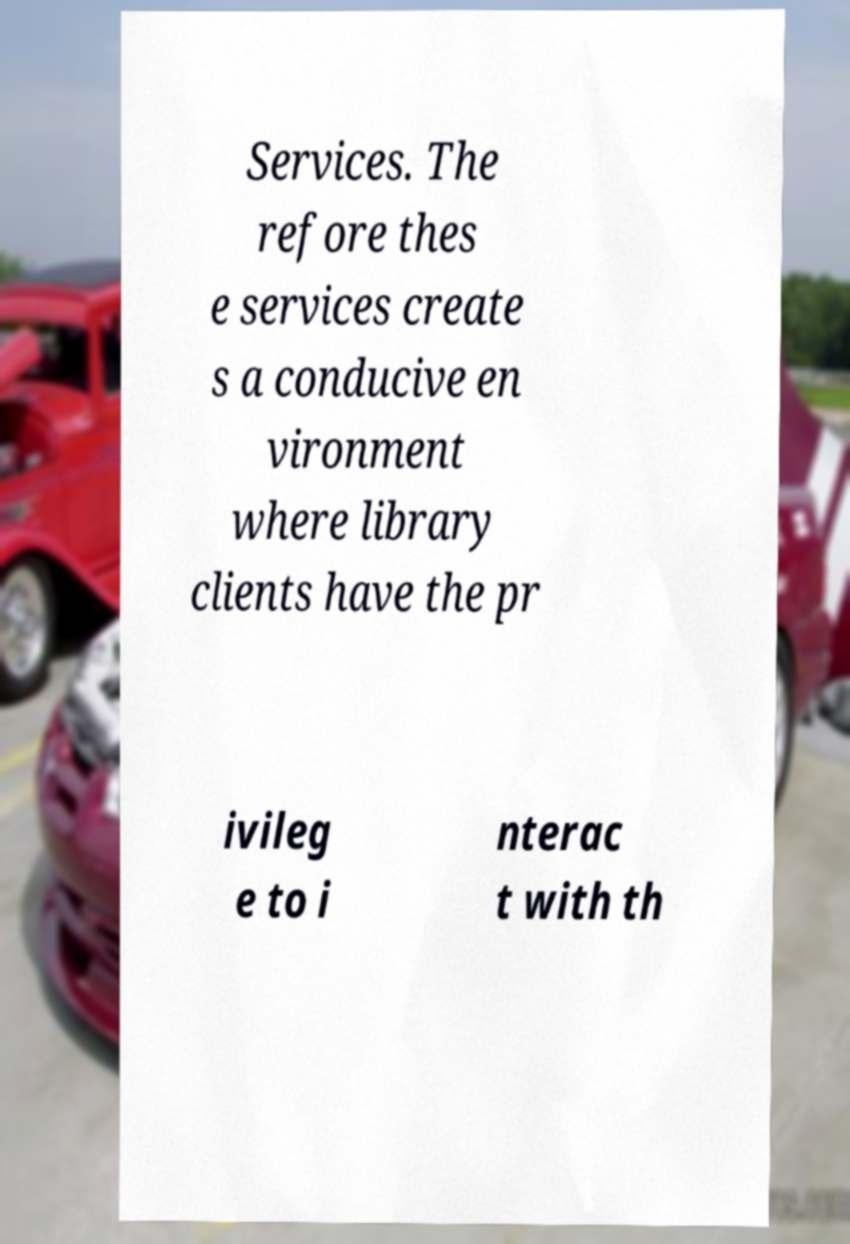Could you extract and type out the text from this image? Services. The refore thes e services create s a conducive en vironment where library clients have the pr ivileg e to i nterac t with th 